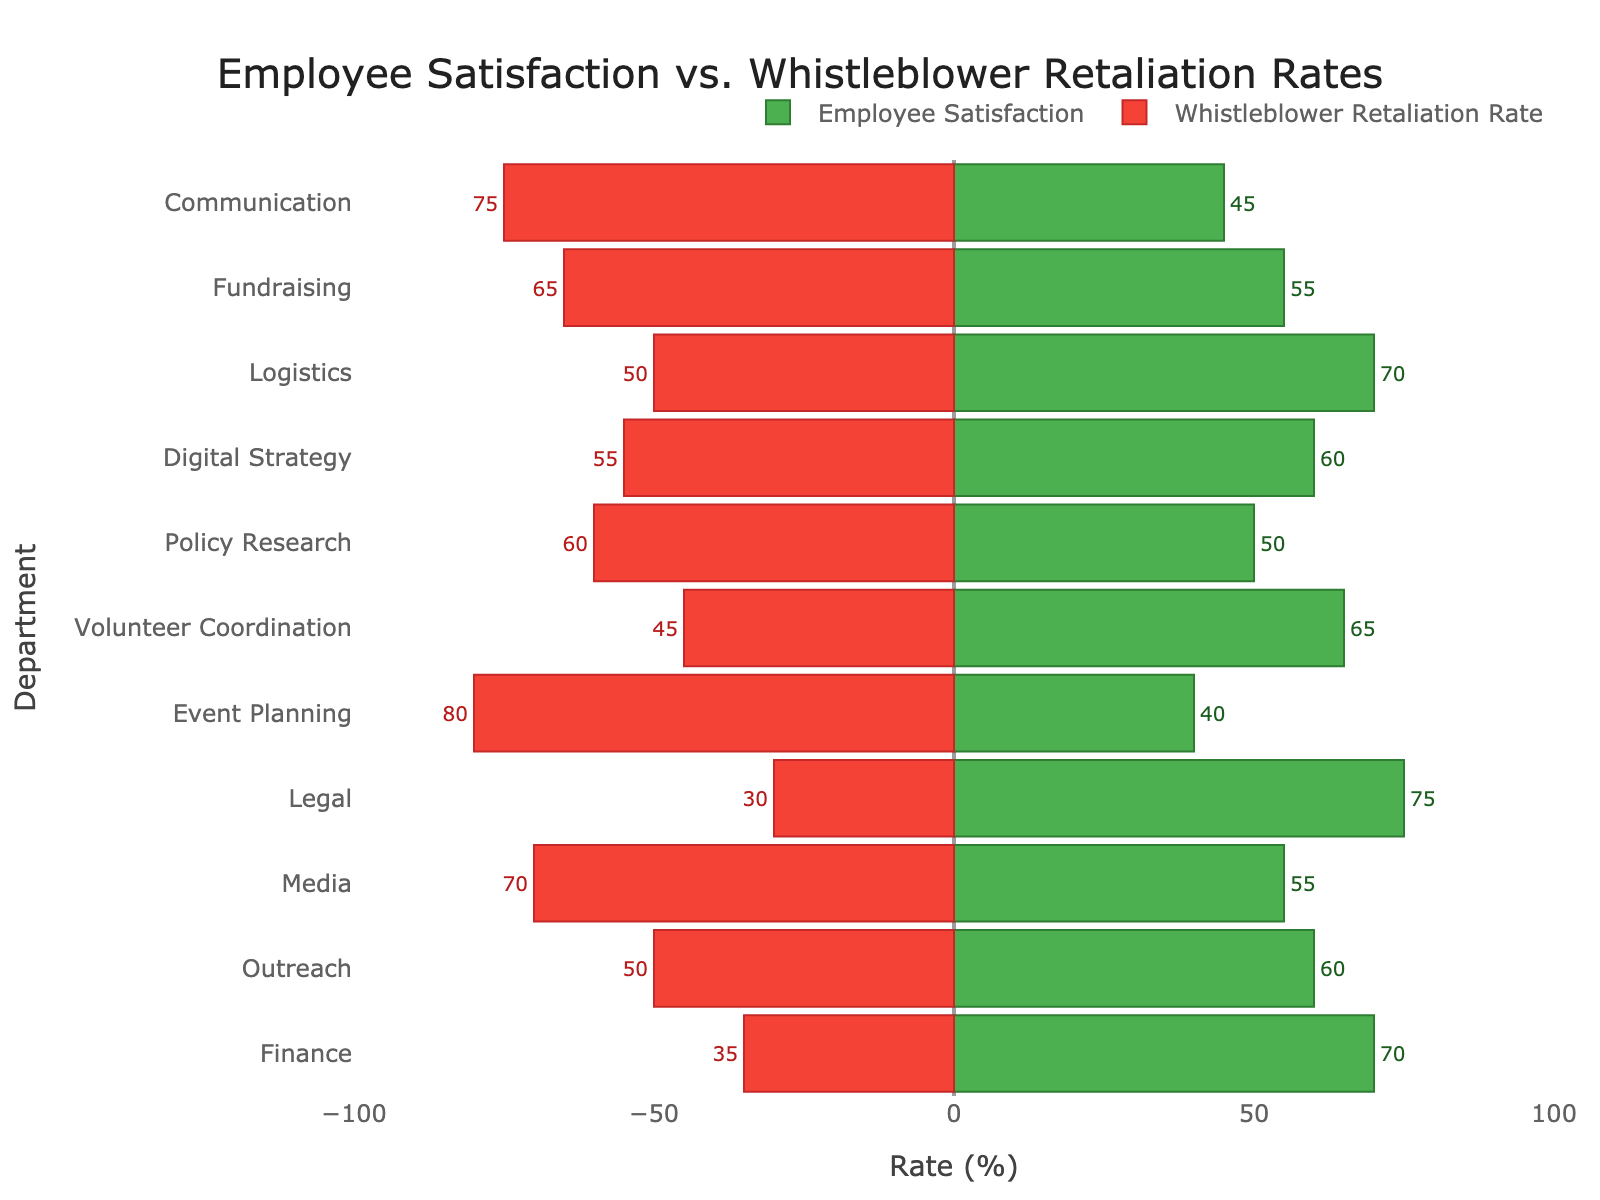Which department has the highest employee satisfaction? The department with the highest employee satisfaction is represented by the longest green bar.
Answer: Legal Which department has the highest whistleblower retaliation rate? The department with the highest whistleblower retaliation rate is represented by the longest red bar.
Answer: Event Planning Which two departments have the same employee satisfaction rate? Check for the green bars that have the same length and numerical value attached to them.
Answer: Digital Strategy and Outreach What is the difference in employee satisfaction between the department with the highest and the department with the lowest satisfaction rates? The department with the highest satisfaction is Legal (75) and the department with the lowest is Event Planning (40). Subtract these values: 75 - 40 = 35.
Answer: 35 What is the combined whistleblower retaliation rate for the Communication and Media departments? Add the whistleblower retaliation rates of the Communication (75) and Media (70) departments: 75 + 70 = 145.
Answer: 145 Which department has a lower employee satisfaction rate than its whistleblower retaliation rate? Compare the lengths of the green and red bars for each department, looking for instances where the green bar is shorter.
Answer: Communication, Policy Research, Event Planning, Media What is the difference between employee satisfaction and whistleblower retaliation rates in the Fundraising department? Subtract the whistleblower retaliation rate (65) from the employee satisfaction rate (55) for Fundraising: 55 - 65 = -10.
Answer: -10 Which department has the closest values of employee satisfaction and whistleblower retaliation rates? Find the department where the green and red bars are nearly equal in length.
Answer: Digital Strategy Arrange the departments in descending order of employee satisfaction. List out the departments according to the lengths of the green bars from longest to shortest.
Answer: Legal, Finance, Logistics, Volunteer Coordination, Digital Strategy, Outreach, Fundraising, Media, Policy Research, Communication, Event Planning How does the whistleblower retaliation rate in the Legal department compare to the employee satisfaction rate in the Finance department? Compare the lengths and numerical values of the red bar for Legal (30) and the green bar for Finance (70).
Answer: Lower 